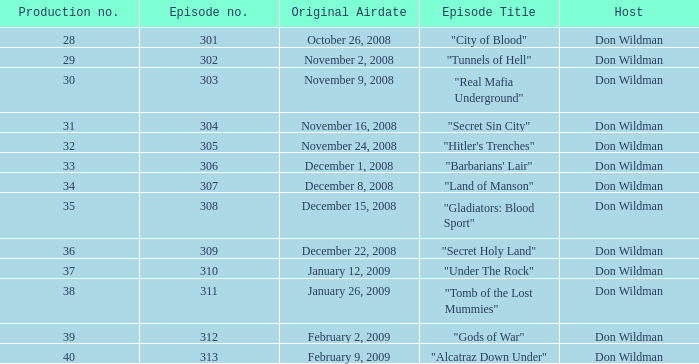What is the episode number of the episode that first aired on january 26, 2009 and had a production number lower than 38? 0.0. 